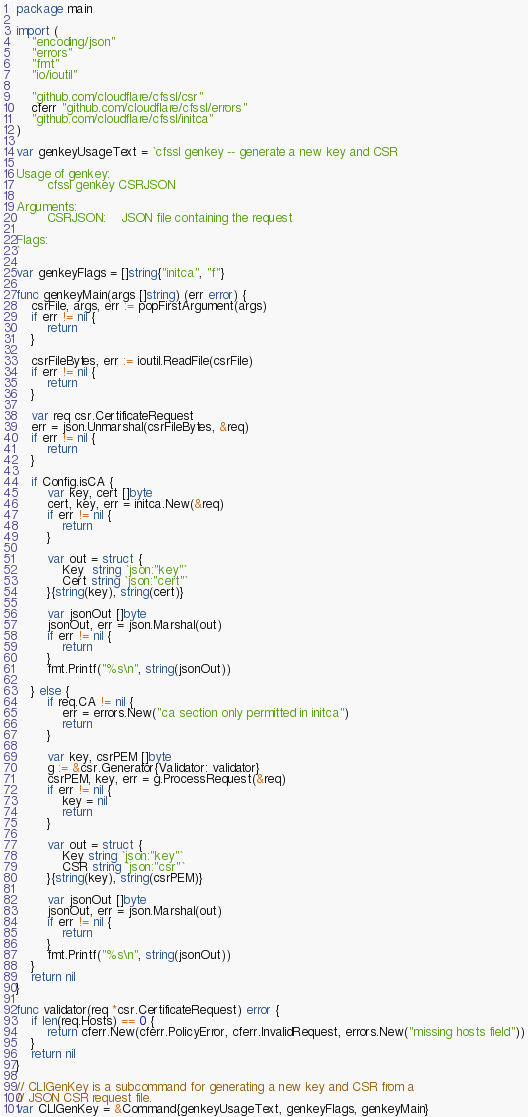Convert code to text. <code><loc_0><loc_0><loc_500><loc_500><_Go_>package main

import (
	"encoding/json"
	"errors"
	"fmt"
	"io/ioutil"

	"github.com/cloudflare/cfssl/csr"
	cferr "github.com/cloudflare/cfssl/errors"
	"github.com/cloudflare/cfssl/initca"
)

var genkeyUsageText = `cfssl genkey -- generate a new key and CSR

Usage of genkey:
        cfssl genkey CSRJSON

Arguments:
        CSRJSON:	JSON file containing the request

Flags:
`

var genkeyFlags = []string{"initca", "f"}

func genkeyMain(args []string) (err error) {
	csrFile, args, err := popFirstArgument(args)
	if err != nil {
		return
	}

	csrFileBytes, err := ioutil.ReadFile(csrFile)
	if err != nil {
		return
	}

	var req csr.CertificateRequest
	err = json.Unmarshal(csrFileBytes, &req)
	if err != nil {
		return
	}

	if Config.isCA {
		var key, cert []byte
		cert, key, err = initca.New(&req)
		if err != nil {
			return
		}

		var out = struct {
			Key  string `json:"key"`
			Cert string `json:"cert"`
		}{string(key), string(cert)}

		var jsonOut []byte
		jsonOut, err = json.Marshal(out)
		if err != nil {
			return
		}
		fmt.Printf("%s\n", string(jsonOut))

	} else {
		if req.CA != nil {
			err = errors.New("ca section only permitted in initca")
			return
		}

		var key, csrPEM []byte
		g := &csr.Generator{Validator: validator}
		csrPEM, key, err = g.ProcessRequest(&req)
		if err != nil {
			key = nil
			return
		}

		var out = struct {
			Key string `json:"key"`
			CSR string `json:"csr"`
		}{string(key), string(csrPEM)}

		var jsonOut []byte
		jsonOut, err = json.Marshal(out)
		if err != nil {
			return
		}
		fmt.Printf("%s\n", string(jsonOut))
	}
	return nil
}

func validator(req *csr.CertificateRequest) error {
	if len(req.Hosts) == 0 {
		return cferr.New(cferr.PolicyError, cferr.InvalidRequest, errors.New("missing hosts field"))
	}
	return nil
}

// CLIGenKey is a subcommand for generating a new key and CSR from a
// JSON CSR request file.
var CLIGenKey = &Command{genkeyUsageText, genkeyFlags, genkeyMain}
</code> 